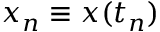<formula> <loc_0><loc_0><loc_500><loc_500>x _ { n } \equiv x ( t _ { n } )</formula> 